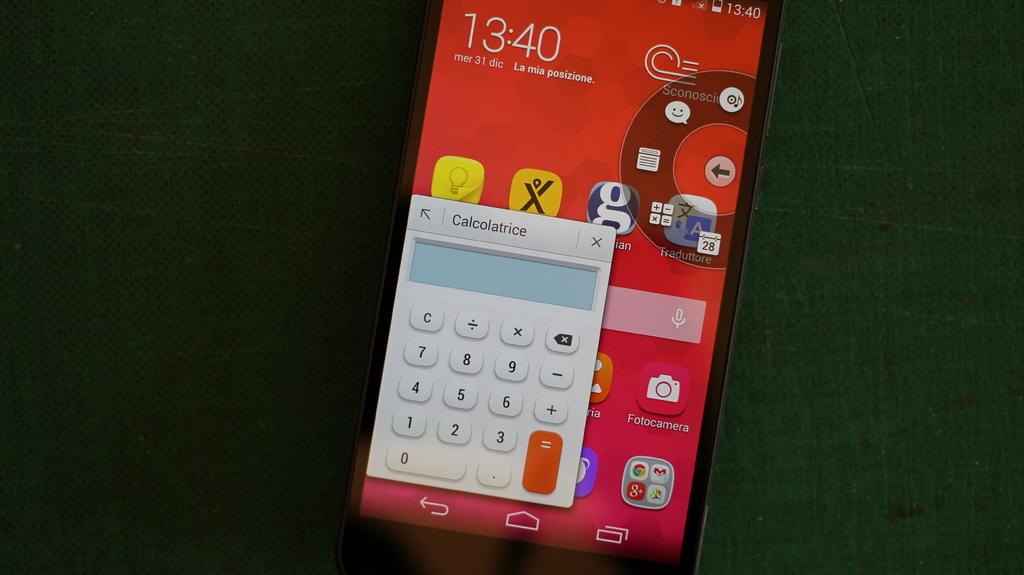What time does the phone say?
Your answer should be very brief. 13:40. Is that a calculator?
Offer a terse response. Yes. 